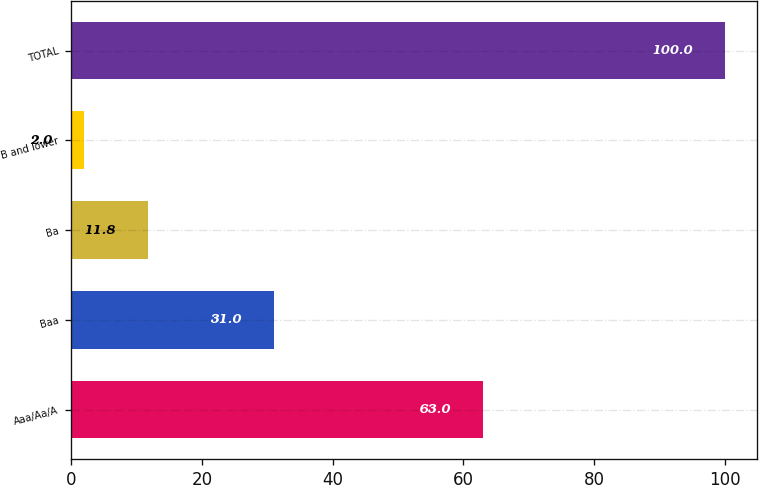Convert chart to OTSL. <chart><loc_0><loc_0><loc_500><loc_500><bar_chart><fcel>Aaa/Aa/A<fcel>Baa<fcel>Ba<fcel>B and lower<fcel>TOTAL<nl><fcel>63<fcel>31<fcel>11.8<fcel>2<fcel>100<nl></chart> 